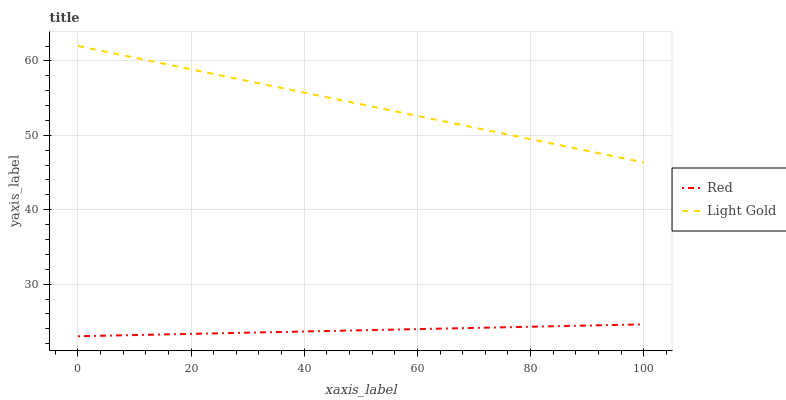Does Red have the minimum area under the curve?
Answer yes or no. Yes. Does Light Gold have the maximum area under the curve?
Answer yes or no. Yes. Does Red have the maximum area under the curve?
Answer yes or no. No. Is Red the smoothest?
Answer yes or no. Yes. Is Light Gold the roughest?
Answer yes or no. Yes. Is Red the roughest?
Answer yes or no. No. Does Red have the lowest value?
Answer yes or no. Yes. Does Light Gold have the highest value?
Answer yes or no. Yes. Does Red have the highest value?
Answer yes or no. No. Is Red less than Light Gold?
Answer yes or no. Yes. Is Light Gold greater than Red?
Answer yes or no. Yes. Does Red intersect Light Gold?
Answer yes or no. No. 